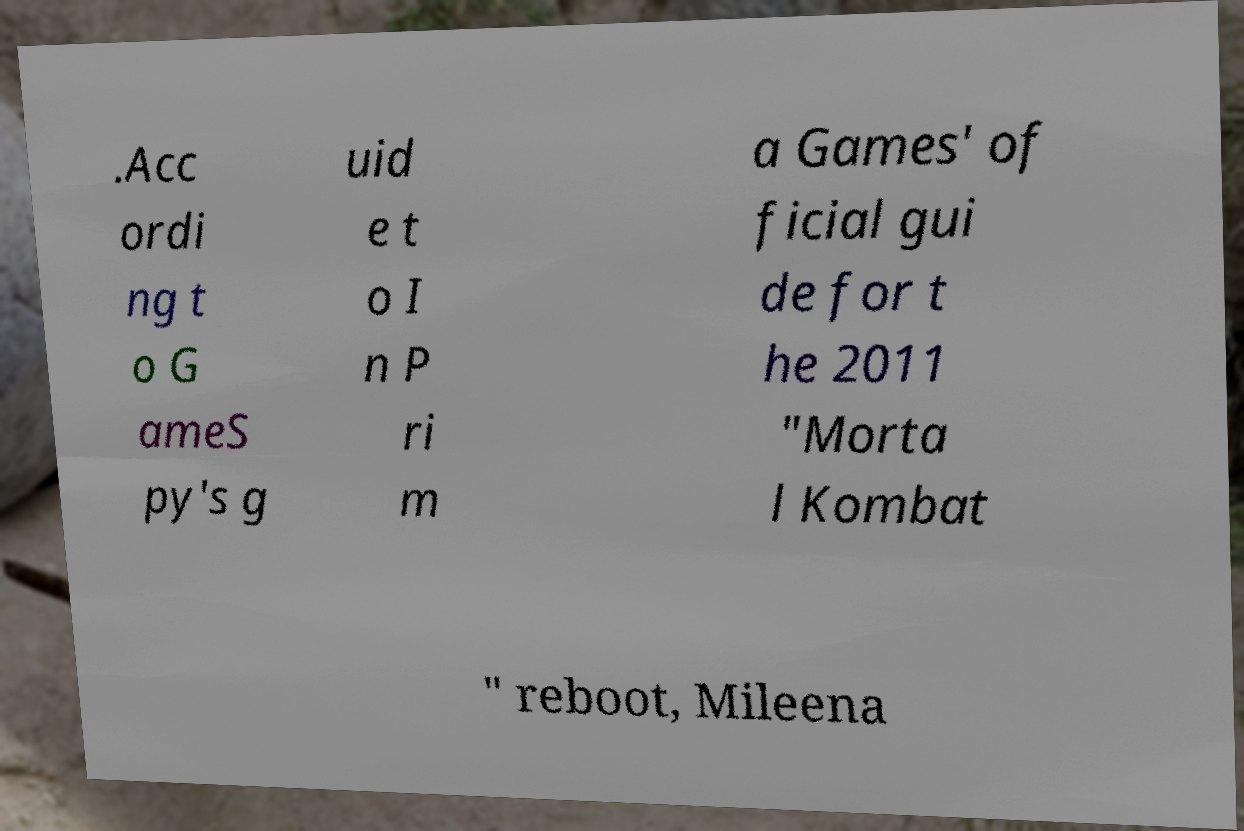Can you accurately transcribe the text from the provided image for me? .Acc ordi ng t o G ameS py's g uid e t o I n P ri m a Games' of ficial gui de for t he 2011 "Morta l Kombat " reboot, Mileena 